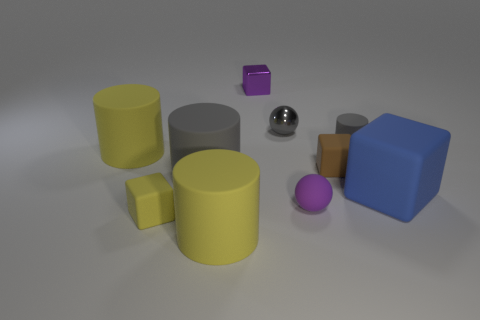Subtract 1 cylinders. How many cylinders are left? 3 Subtract all spheres. How many objects are left? 8 Add 4 tiny gray metal spheres. How many tiny gray metal spheres exist? 5 Subtract 0 green balls. How many objects are left? 10 Subtract all small blue metal cylinders. Subtract all tiny cubes. How many objects are left? 7 Add 5 big blue rubber things. How many big blue rubber things are left? 6 